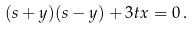<formula> <loc_0><loc_0><loc_500><loc_500>( s + y ) ( s - y ) + 3 t x = 0 \, .</formula> 